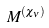Convert formula to latex. <formula><loc_0><loc_0><loc_500><loc_500>M ^ { ( \chi _ { \nu } ) }</formula> 